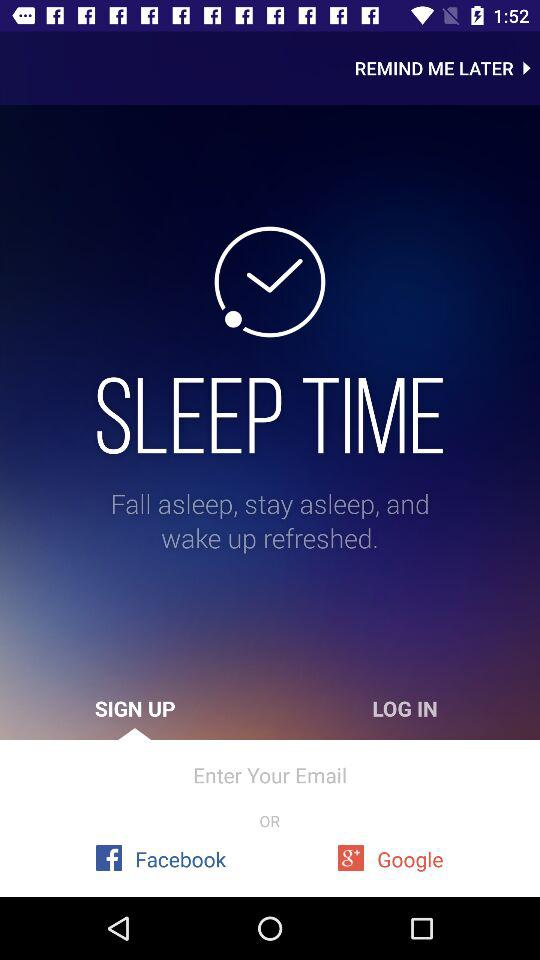Which tab has been selected? The tab that has been selected is "SIGN UP". 